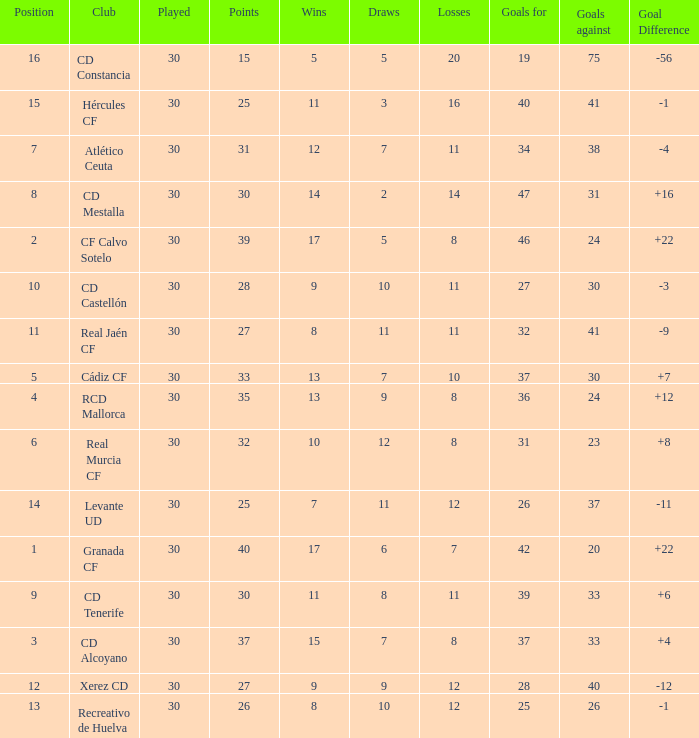How many Wins have Goals against smaller than 30, and Goals for larger than 25, and Draws larger than 5? 3.0. 